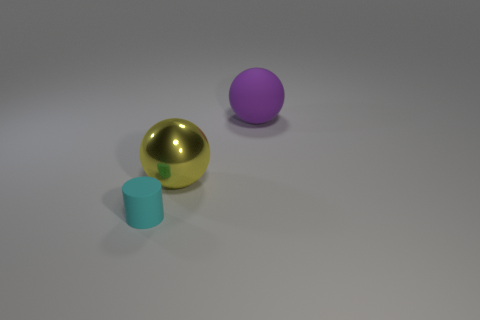Add 2 balls. How many objects exist? 5 Subtract all cylinders. How many objects are left? 2 Add 1 yellow metal objects. How many yellow metal objects exist? 2 Subtract all yellow balls. How many balls are left? 1 Subtract 0 purple cylinders. How many objects are left? 3 Subtract 2 spheres. How many spheres are left? 0 Subtract all red spheres. Subtract all green cubes. How many spheres are left? 2 Subtract all cyan blocks. How many brown balls are left? 0 Subtract all large matte objects. Subtract all small cyan matte cylinders. How many objects are left? 1 Add 1 cyan cylinders. How many cyan cylinders are left? 2 